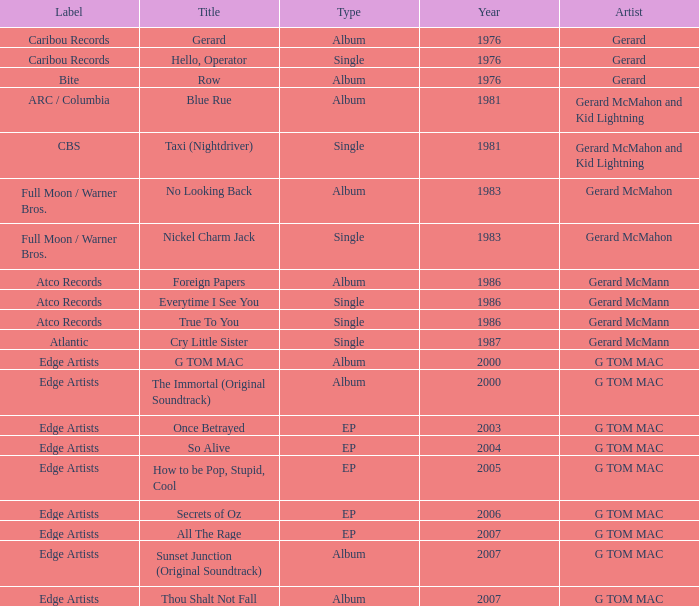Which Title has a Type of album in 1983? No Looking Back. 